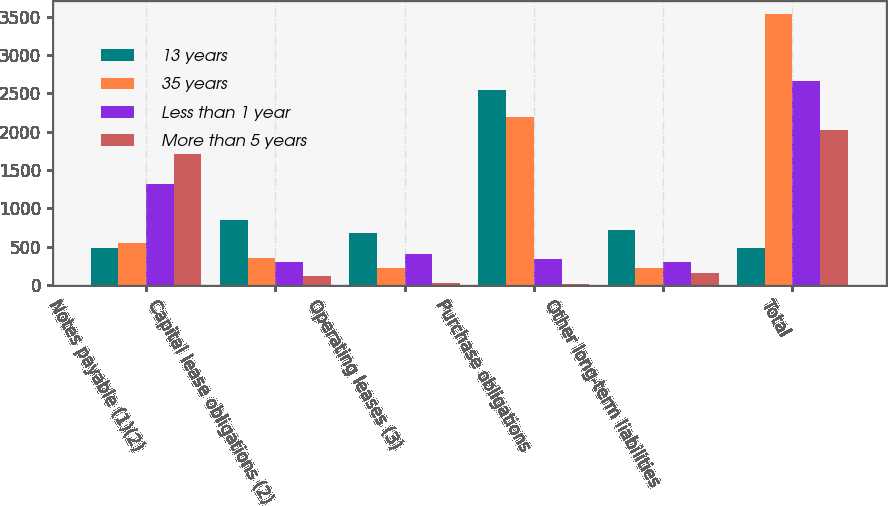<chart> <loc_0><loc_0><loc_500><loc_500><stacked_bar_chart><ecel><fcel>Notes payable (1)(2)<fcel>Capital lease obligations (2)<fcel>Operating leases (3)<fcel>Purchase obligations<fcel>Other long-term liabilities<fcel>Total<nl><fcel>13 years<fcel>479<fcel>852<fcel>682<fcel>2545<fcel>716<fcel>479<nl><fcel>35 years<fcel>556<fcel>349<fcel>218<fcel>2189<fcel>222<fcel>3534<nl><fcel>Less than 1 year<fcel>1315<fcel>304<fcel>402<fcel>335<fcel>304<fcel>2660<nl><fcel>More than 5 years<fcel>1712<fcel>123<fcel>27<fcel>11<fcel>152<fcel>2025<nl></chart> 